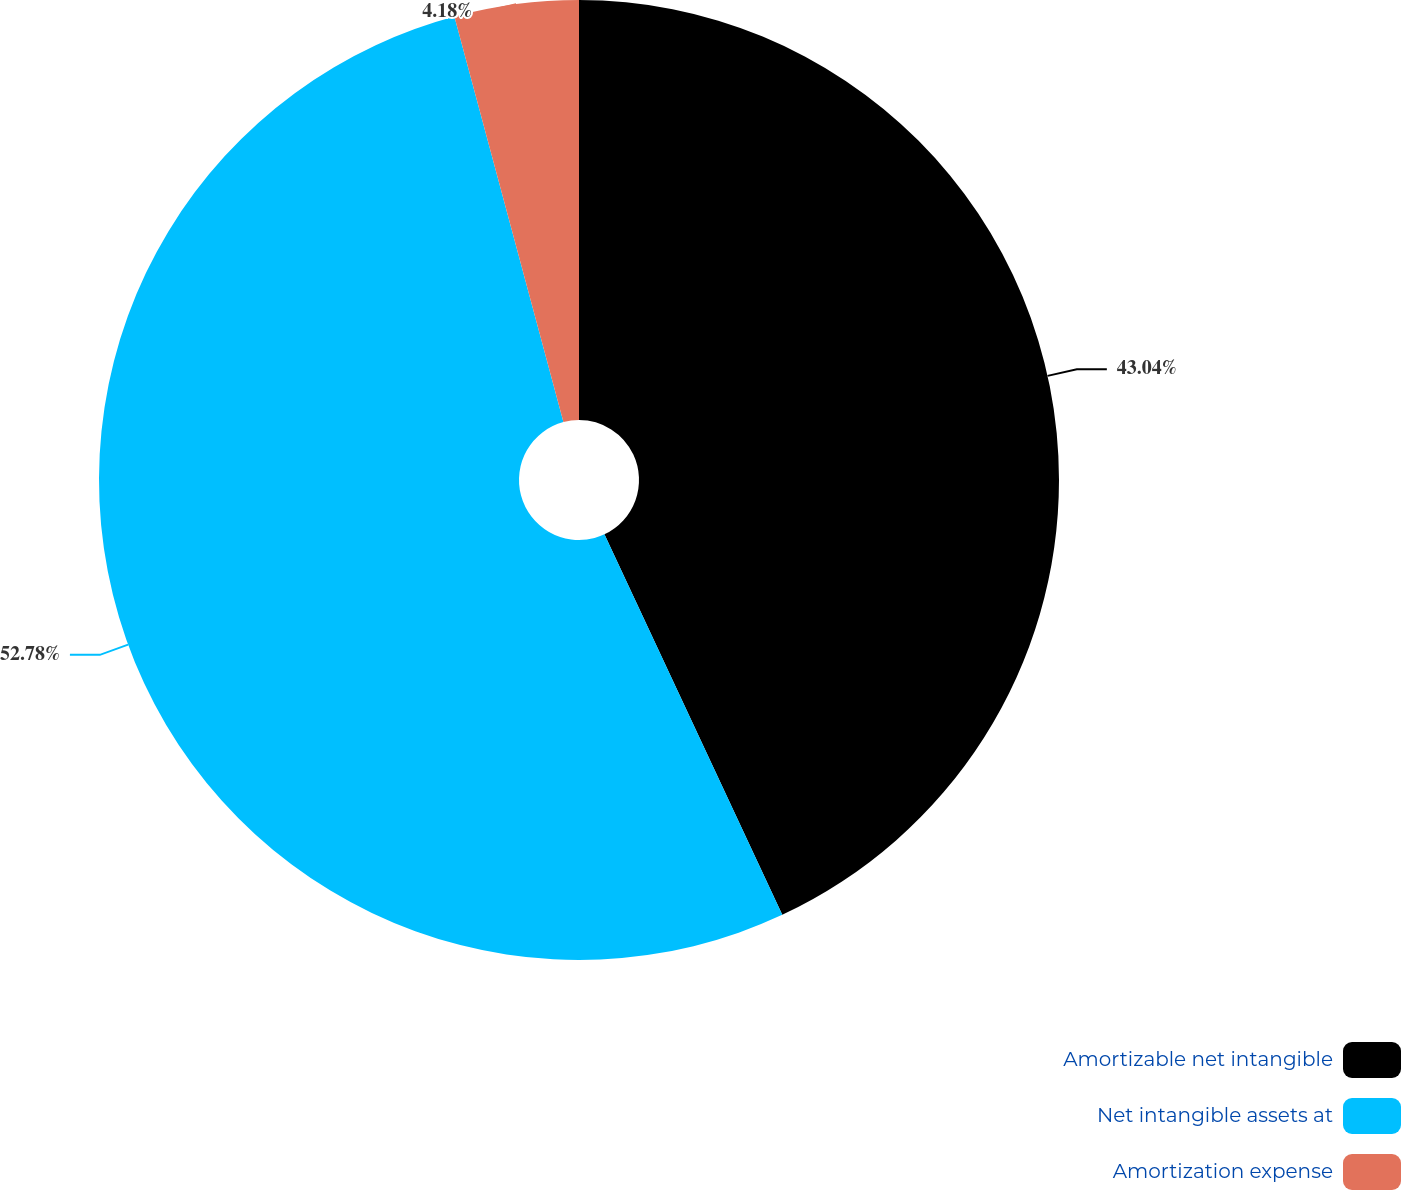Convert chart. <chart><loc_0><loc_0><loc_500><loc_500><pie_chart><fcel>Amortizable net intangible<fcel>Net intangible assets at<fcel>Amortization expense<nl><fcel>43.04%<fcel>52.78%<fcel>4.18%<nl></chart> 